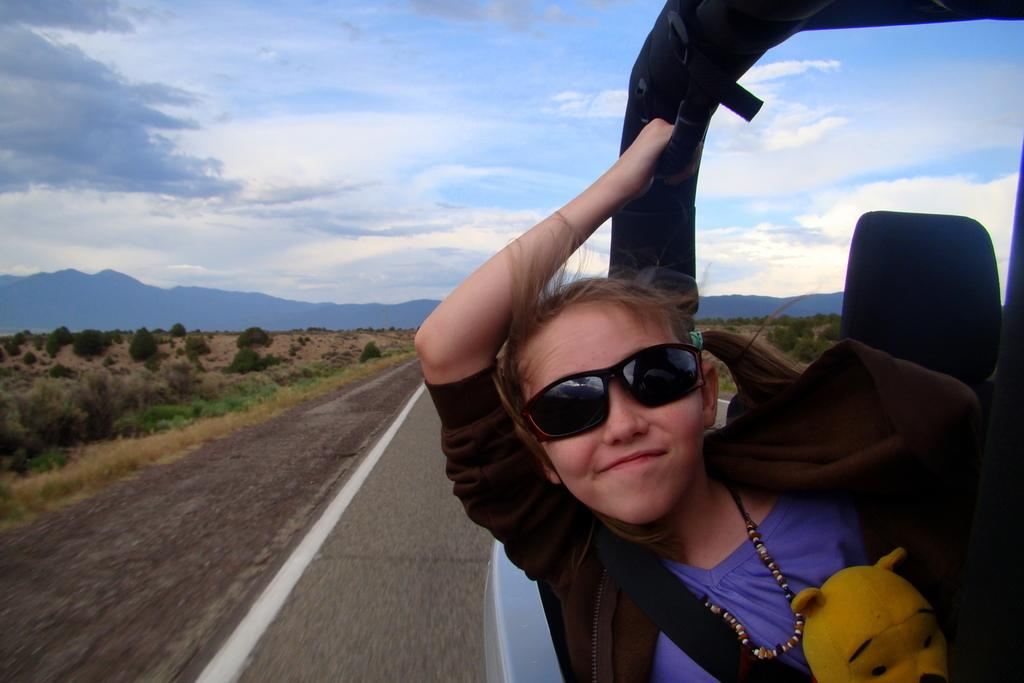Who is the main subject in the image? There is a girl in the image. What is the girl holding in the image? The girl is holding a carp rod. What is the girl's expression in the image? The girl is smiling. What can be seen in the background of the image? There is a road, grass, plants, and the sky visible in the background of the image. What is the condition of the sky in the image? Clouds are present in the sky. What type of bit is the girl using to control the bedroom in the image? There is no bedroom or bit present in the image; it features a girl holding a carp rod and smiling. 